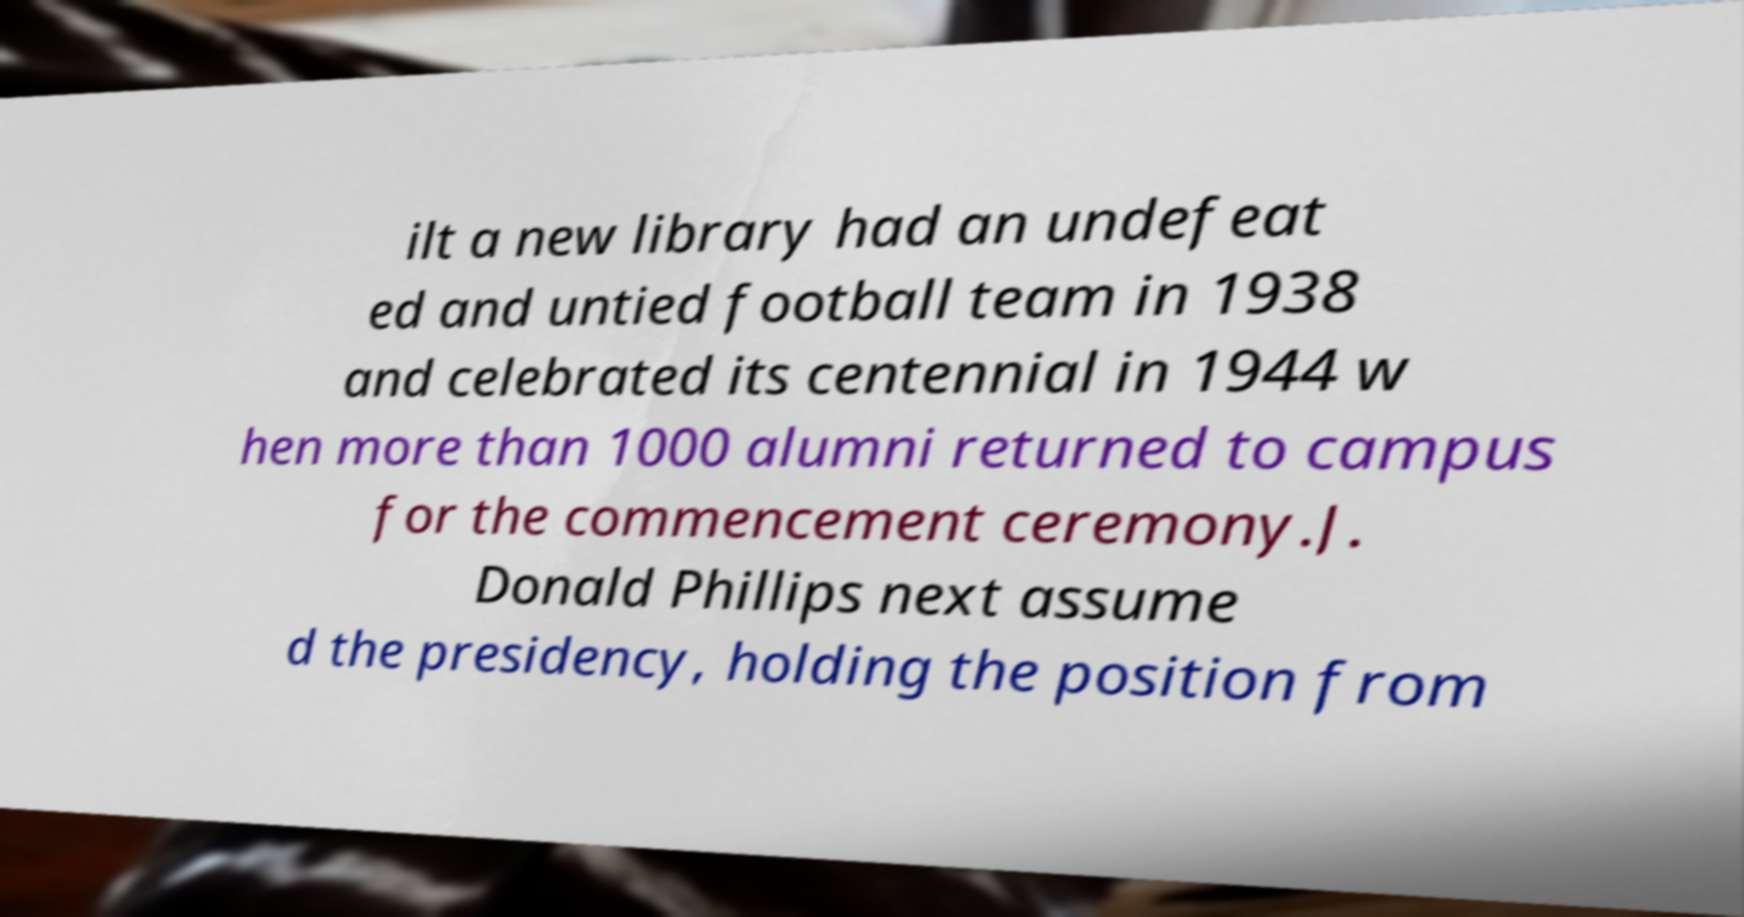For documentation purposes, I need the text within this image transcribed. Could you provide that? ilt a new library had an undefeat ed and untied football team in 1938 and celebrated its centennial in 1944 w hen more than 1000 alumni returned to campus for the commencement ceremony.J. Donald Phillips next assume d the presidency, holding the position from 